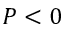Convert formula to latex. <formula><loc_0><loc_0><loc_500><loc_500>P < 0</formula> 